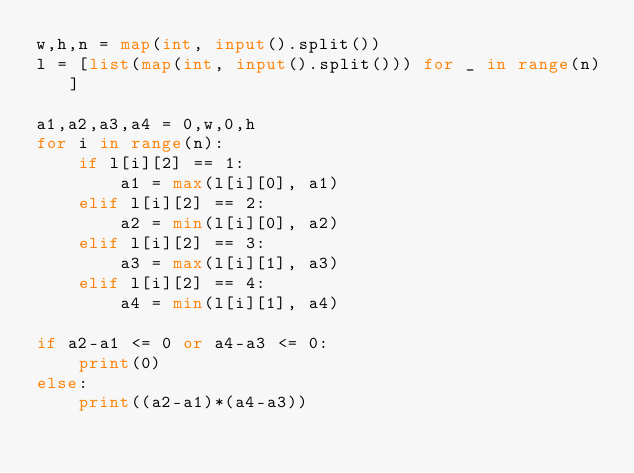Convert code to text. <code><loc_0><loc_0><loc_500><loc_500><_Python_>w,h,n = map(int, input().split())
l = [list(map(int, input().split())) for _ in range(n)]

a1,a2,a3,a4 = 0,w,0,h
for i in range(n):
    if l[i][2] == 1:
        a1 = max(l[i][0], a1)
    elif l[i][2] == 2:
        a2 = min(l[i][0], a2)
    elif l[i][2] == 3:
        a3 = max(l[i][1], a3)
    elif l[i][2] == 4:
        a4 = min(l[i][1], a4)

if a2-a1 <= 0 or a4-a3 <= 0:
    print(0)
else:
    print((a2-a1)*(a4-a3))
</code> 